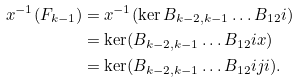Convert formula to latex. <formula><loc_0><loc_0><loc_500><loc_500>x ^ { - 1 } ( F _ { k - 1 } ) & = x ^ { - 1 } ( \ker B _ { k - 2 , k - 1 } \dots B _ { 1 2 } i ) \\ & = \ker ( B _ { k - 2 , k - 1 } \dots B _ { 1 2 } i x ) \\ & = \ker ( B _ { k - 2 , k - 1 } \dots B _ { 1 2 } i j i ) .</formula> 